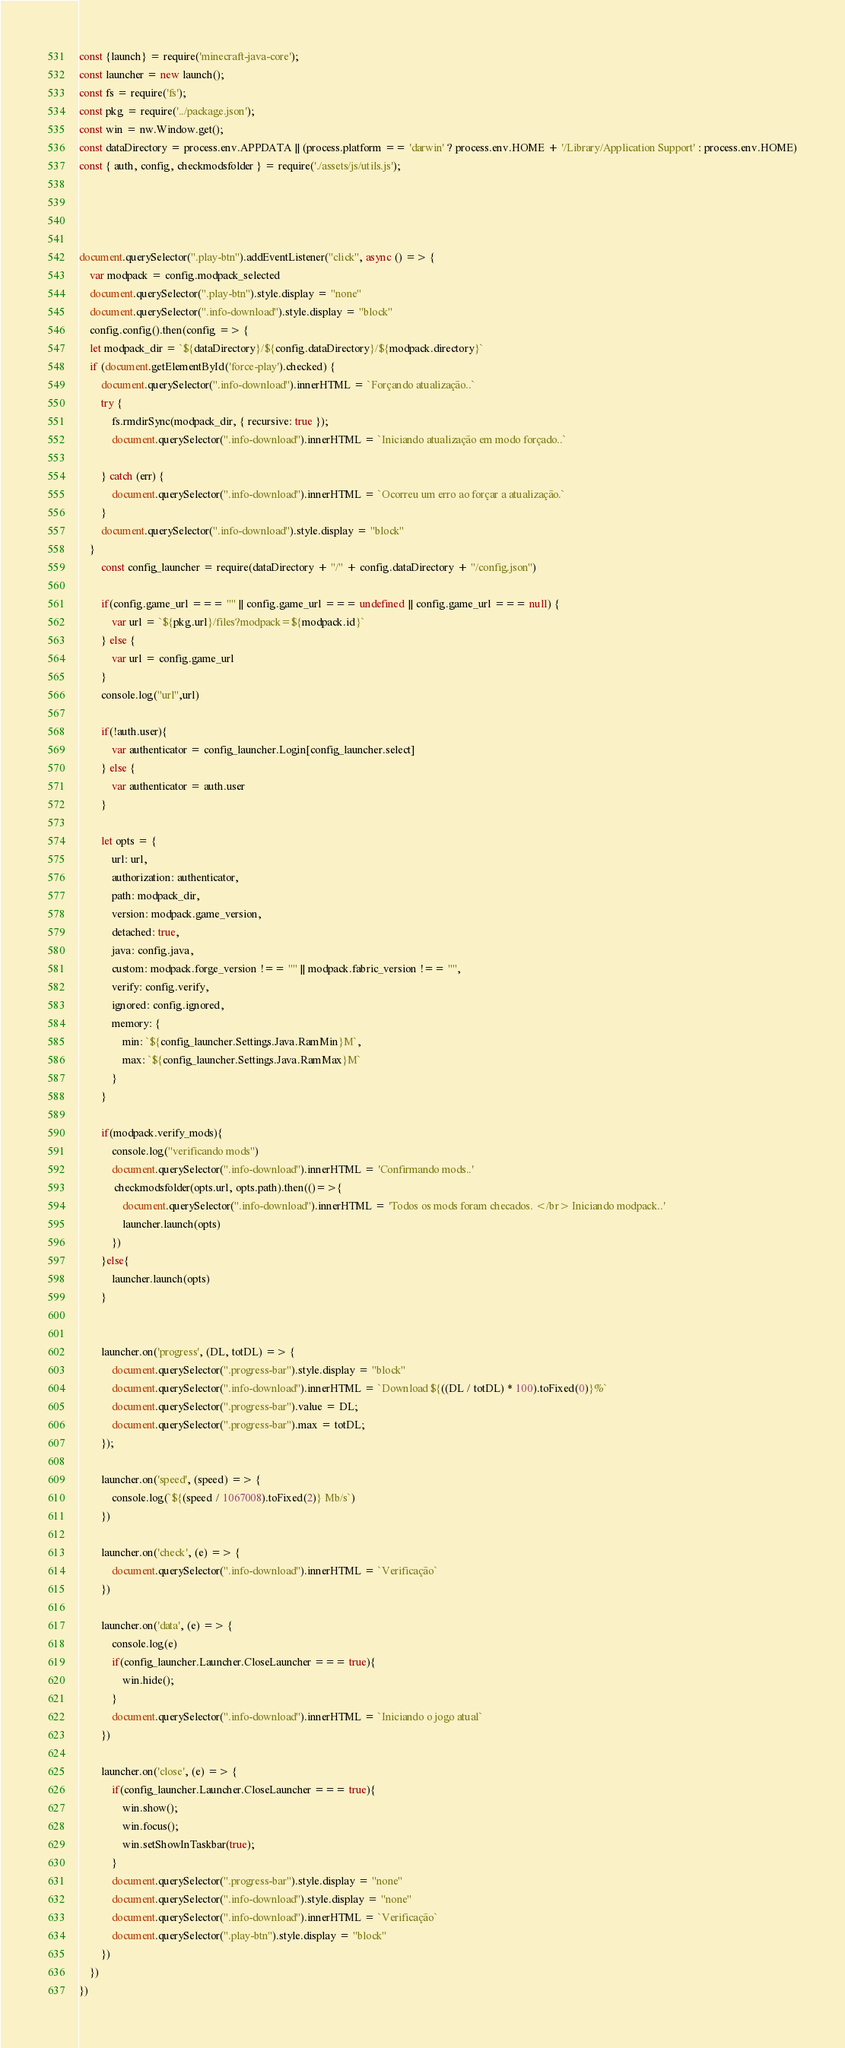<code> <loc_0><loc_0><loc_500><loc_500><_JavaScript_>const {launch} = require('minecraft-java-core');
const launcher = new launch();
const fs = require('fs');
const pkg = require('../package.json');
const win = nw.Window.get();
const dataDirectory = process.env.APPDATA || (process.platform == 'darwin' ? process.env.HOME + '/Library/Application Support' : process.env.HOME)
const { auth, config, checkmodsfolder } = require('./assets/js/utils.js');




document.querySelector(".play-btn").addEventListener("click", async () => {
    var modpack = config.modpack_selected
    document.querySelector(".play-btn").style.display = "none"
    document.querySelector(".info-download").style.display = "block"
    config.config().then(config => {
    let modpack_dir = `${dataDirectory}/${config.dataDirectory}/${modpack.directory}`
    if (document.getElementById('force-play').checked) {
        document.querySelector(".info-download").innerHTML = `Forçando atualização..`
        try {
            fs.rmdirSync(modpack_dir, { recursive: true });
            document.querySelector(".info-download").innerHTML = `Iniciando atualização em modo forçado..`

        } catch (err) {
            document.querySelector(".info-download").innerHTML = `Ocorreu um erro ao forçar a atualização.`
        }
        document.querySelector(".info-download").style.display = "block"
    }
        const config_launcher = require(dataDirectory + "/" + config.dataDirectory + "/config.json")

        if(config.game_url === "" || config.game_url === undefined || config.game_url === null) {
            var url = `${pkg.url}/files?modpack=${modpack.id}`
        } else {
            var url = config.game_url
        }
        console.log("url",url)

        if(!auth.user){
            var authenticator = config_launcher.Login[config_launcher.select]       
        } else {
            var authenticator = auth.user
        }
       
        let opts = {
            url: url,
            authorization: authenticator,
            path: modpack_dir,
            version: modpack.game_version,
            detached: true,
            java: config.java,
            custom: modpack.forge_version !== "" || modpack.fabric_version !== "",
            verify: config.verify,
            ignored: config.ignored,
            memory: {
                min: `${config_launcher.Settings.Java.RamMin}M`,
                max: `${config_launcher.Settings.Java.RamMax}M`
            }
        }
        
        if(modpack.verify_mods){
            console.log("verificando mods")
            document.querySelector(".info-download").innerHTML = 'Confirmando mods..'
             checkmodsfolder(opts.url, opts.path).then(()=>{
                document.querySelector(".info-download").innerHTML = 'Todos os mods foram checados. </br> Iniciando modpack..'
                launcher.launch(opts)
            })
        }else{
            launcher.launch(opts)
        }
        
        
        launcher.on('progress', (DL, totDL) => {
            document.querySelector(".progress-bar").style.display = "block"
            document.querySelector(".info-download").innerHTML = `Download ${((DL / totDL) * 100).toFixed(0)}%`
            document.querySelector(".progress-bar").value = DL;
            document.querySelector(".progress-bar").max = totDL;
        });
        
        launcher.on('speed', (speed) => {
            console.log(`${(speed / 1067008).toFixed(2)} Mb/s`)
        })

        launcher.on('check', (e) => {
            document.querySelector(".info-download").innerHTML = `Verificação`
        })
        
        launcher.on('data', (e) => {
            console.log(e)
            if(config_launcher.Launcher.CloseLauncher === true){
                win.hide();
            }
            document.querySelector(".info-download").innerHTML = `Iniciando o jogo atual`
        })
        
        launcher.on('close', (e) => {
            if(config_launcher.Launcher.CloseLauncher === true){
                win.show();
                win.focus();
                win.setShowInTaskbar(true);
            }
            document.querySelector(".progress-bar").style.display = "none"
            document.querySelector(".info-download").style.display = "none"
            document.querySelector(".info-download").innerHTML = `Verificação`
            document.querySelector(".play-btn").style.display = "block"
        })
    })
})</code> 